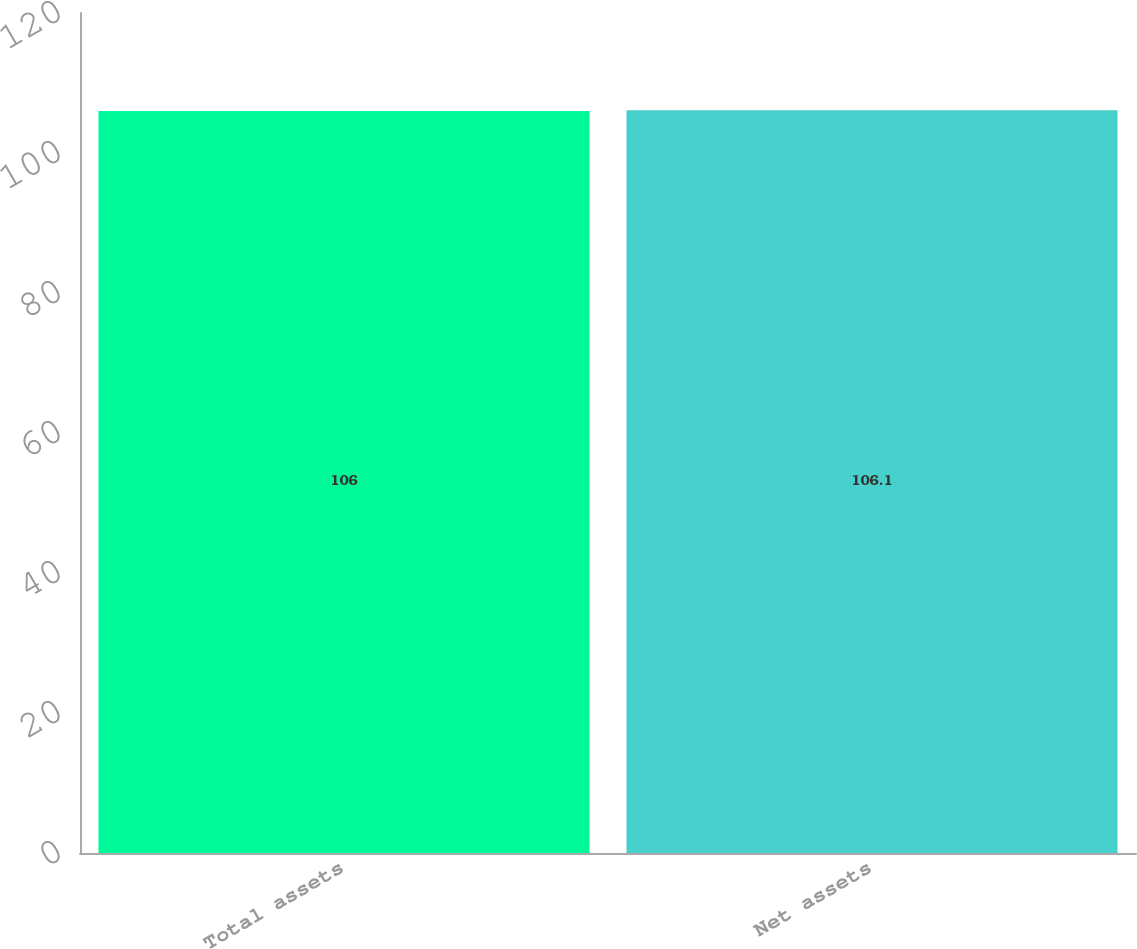Convert chart to OTSL. <chart><loc_0><loc_0><loc_500><loc_500><bar_chart><fcel>Total assets<fcel>Net assets<nl><fcel>106<fcel>106.1<nl></chart> 